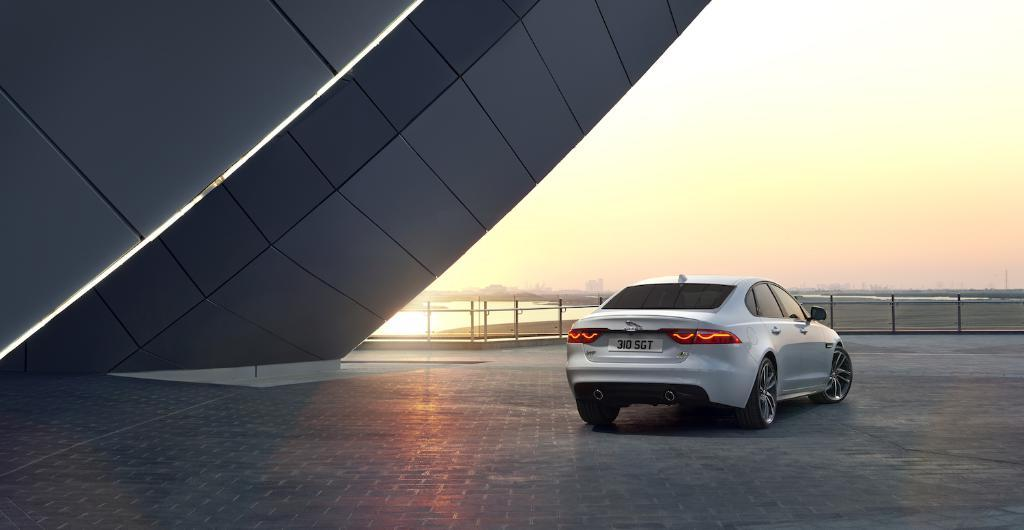What is the main subject of the image? There is a car in the image. Where is the car located? The car is on the road. What is the color of the car? The car is white in color. What can be seen in the background of the image? There is a building, the sky, water, and a fence visible in the background of the image. What type of support can be seen holding up the moon in the image? There is no moon present in the image, so there is no support for it. 